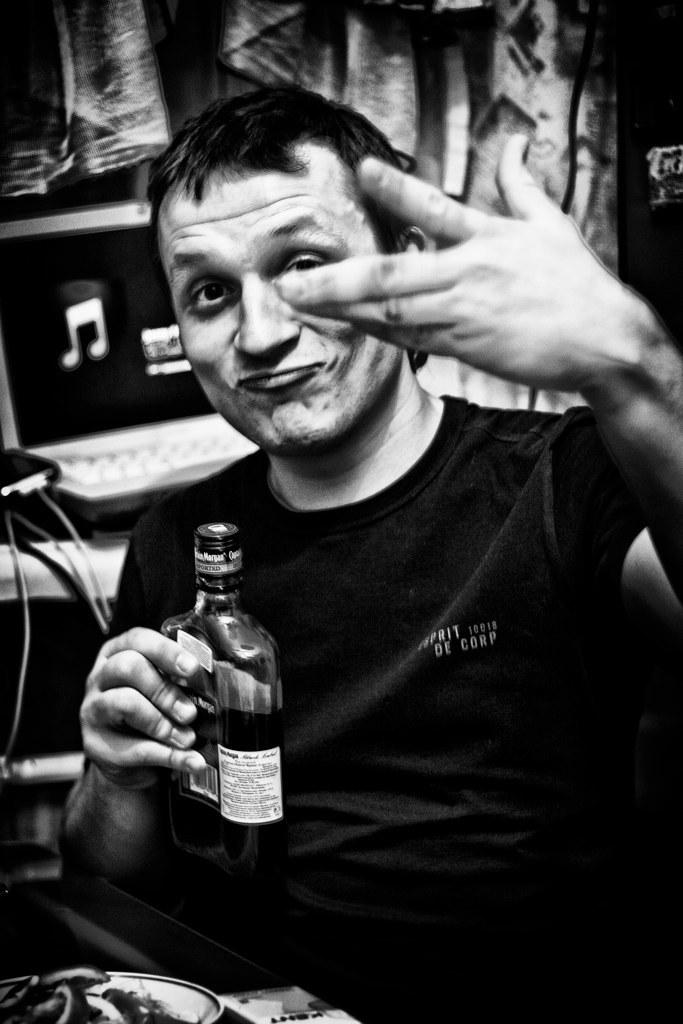What is present in the image? There is a man in the image. What is the man doing in the image? The man is sitting on a chair. What object is the man holding in his hand? The man is holding a wine bottle in his hand. What type of food is the man eating from the wine bottle in the image? The man is not eating any food from the wine bottle in the image; he is holding a wine bottle. What type of event is the man attending in the image? There is no indication of an event in the image; it only shows a man sitting on a chair and holding a wine bottle. 